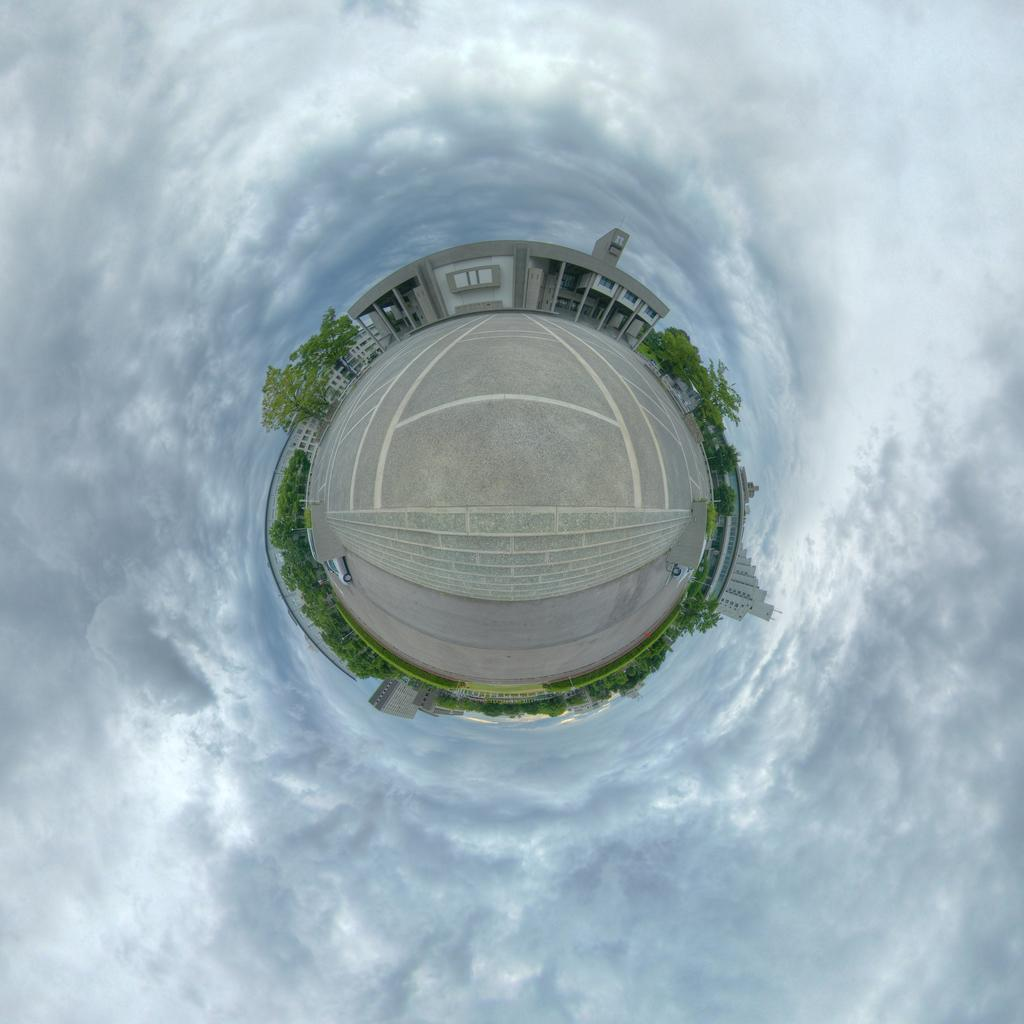What type of image is being described? The image is an animated image. What can be seen in the middle of the image? There are buildings, trees, a car, and a road in the middle of the image. What is visible in the background of the image? There is sky visible in the background of the image, and there are clouds in the background as well. What type of board is being used by the trees in the image? There is no board present in the image, as the trees are not using any objects. What is the stem of the car in the image? There is no stem associated with the car in the image, as cars do not have stems. 